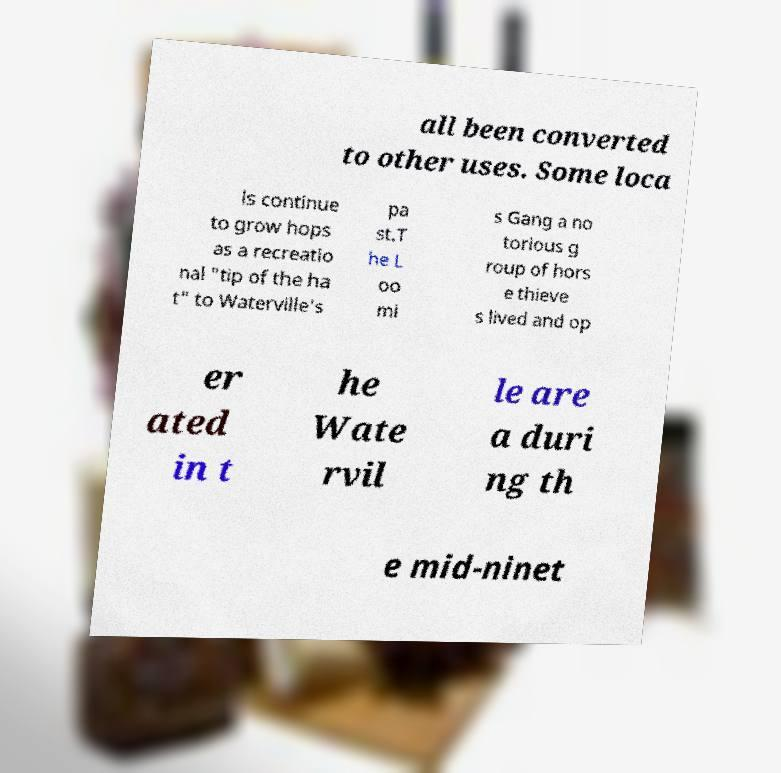Could you assist in decoding the text presented in this image and type it out clearly? all been converted to other uses. Some loca ls continue to grow hops as a recreatio nal "tip of the ha t" to Waterville's pa st.T he L oo mi s Gang a no torious g roup of hors e thieve s lived and op er ated in t he Wate rvil le are a duri ng th e mid-ninet 